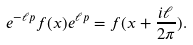<formula> <loc_0><loc_0><loc_500><loc_500>e ^ { - \ell p } f ( x ) e ^ { \ell p } = f ( x + \frac { i \ell } { 2 \pi } ) .</formula> 